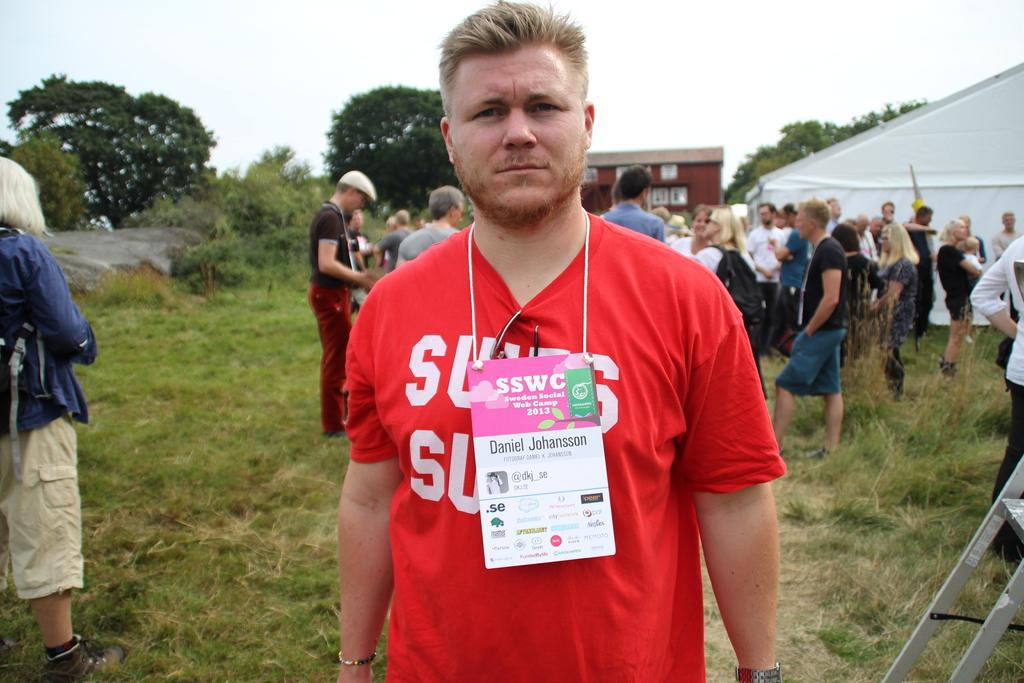What type of vegetation is present in the image? There is grass in the image. Who or what can be seen in the image? There are people in the image. What structure is located on the right side of the image? There is a tent on the right side of the image. What can be seen in the background of the image? There is a building and trees in the background of the image. What part of the natural environment is visible in the image? The sky is visible in the image. How many giraffes are visible in the image? There are no giraffes present in the image. What type of bun is being served on the table in the image? There is no table or bun present in the image. 